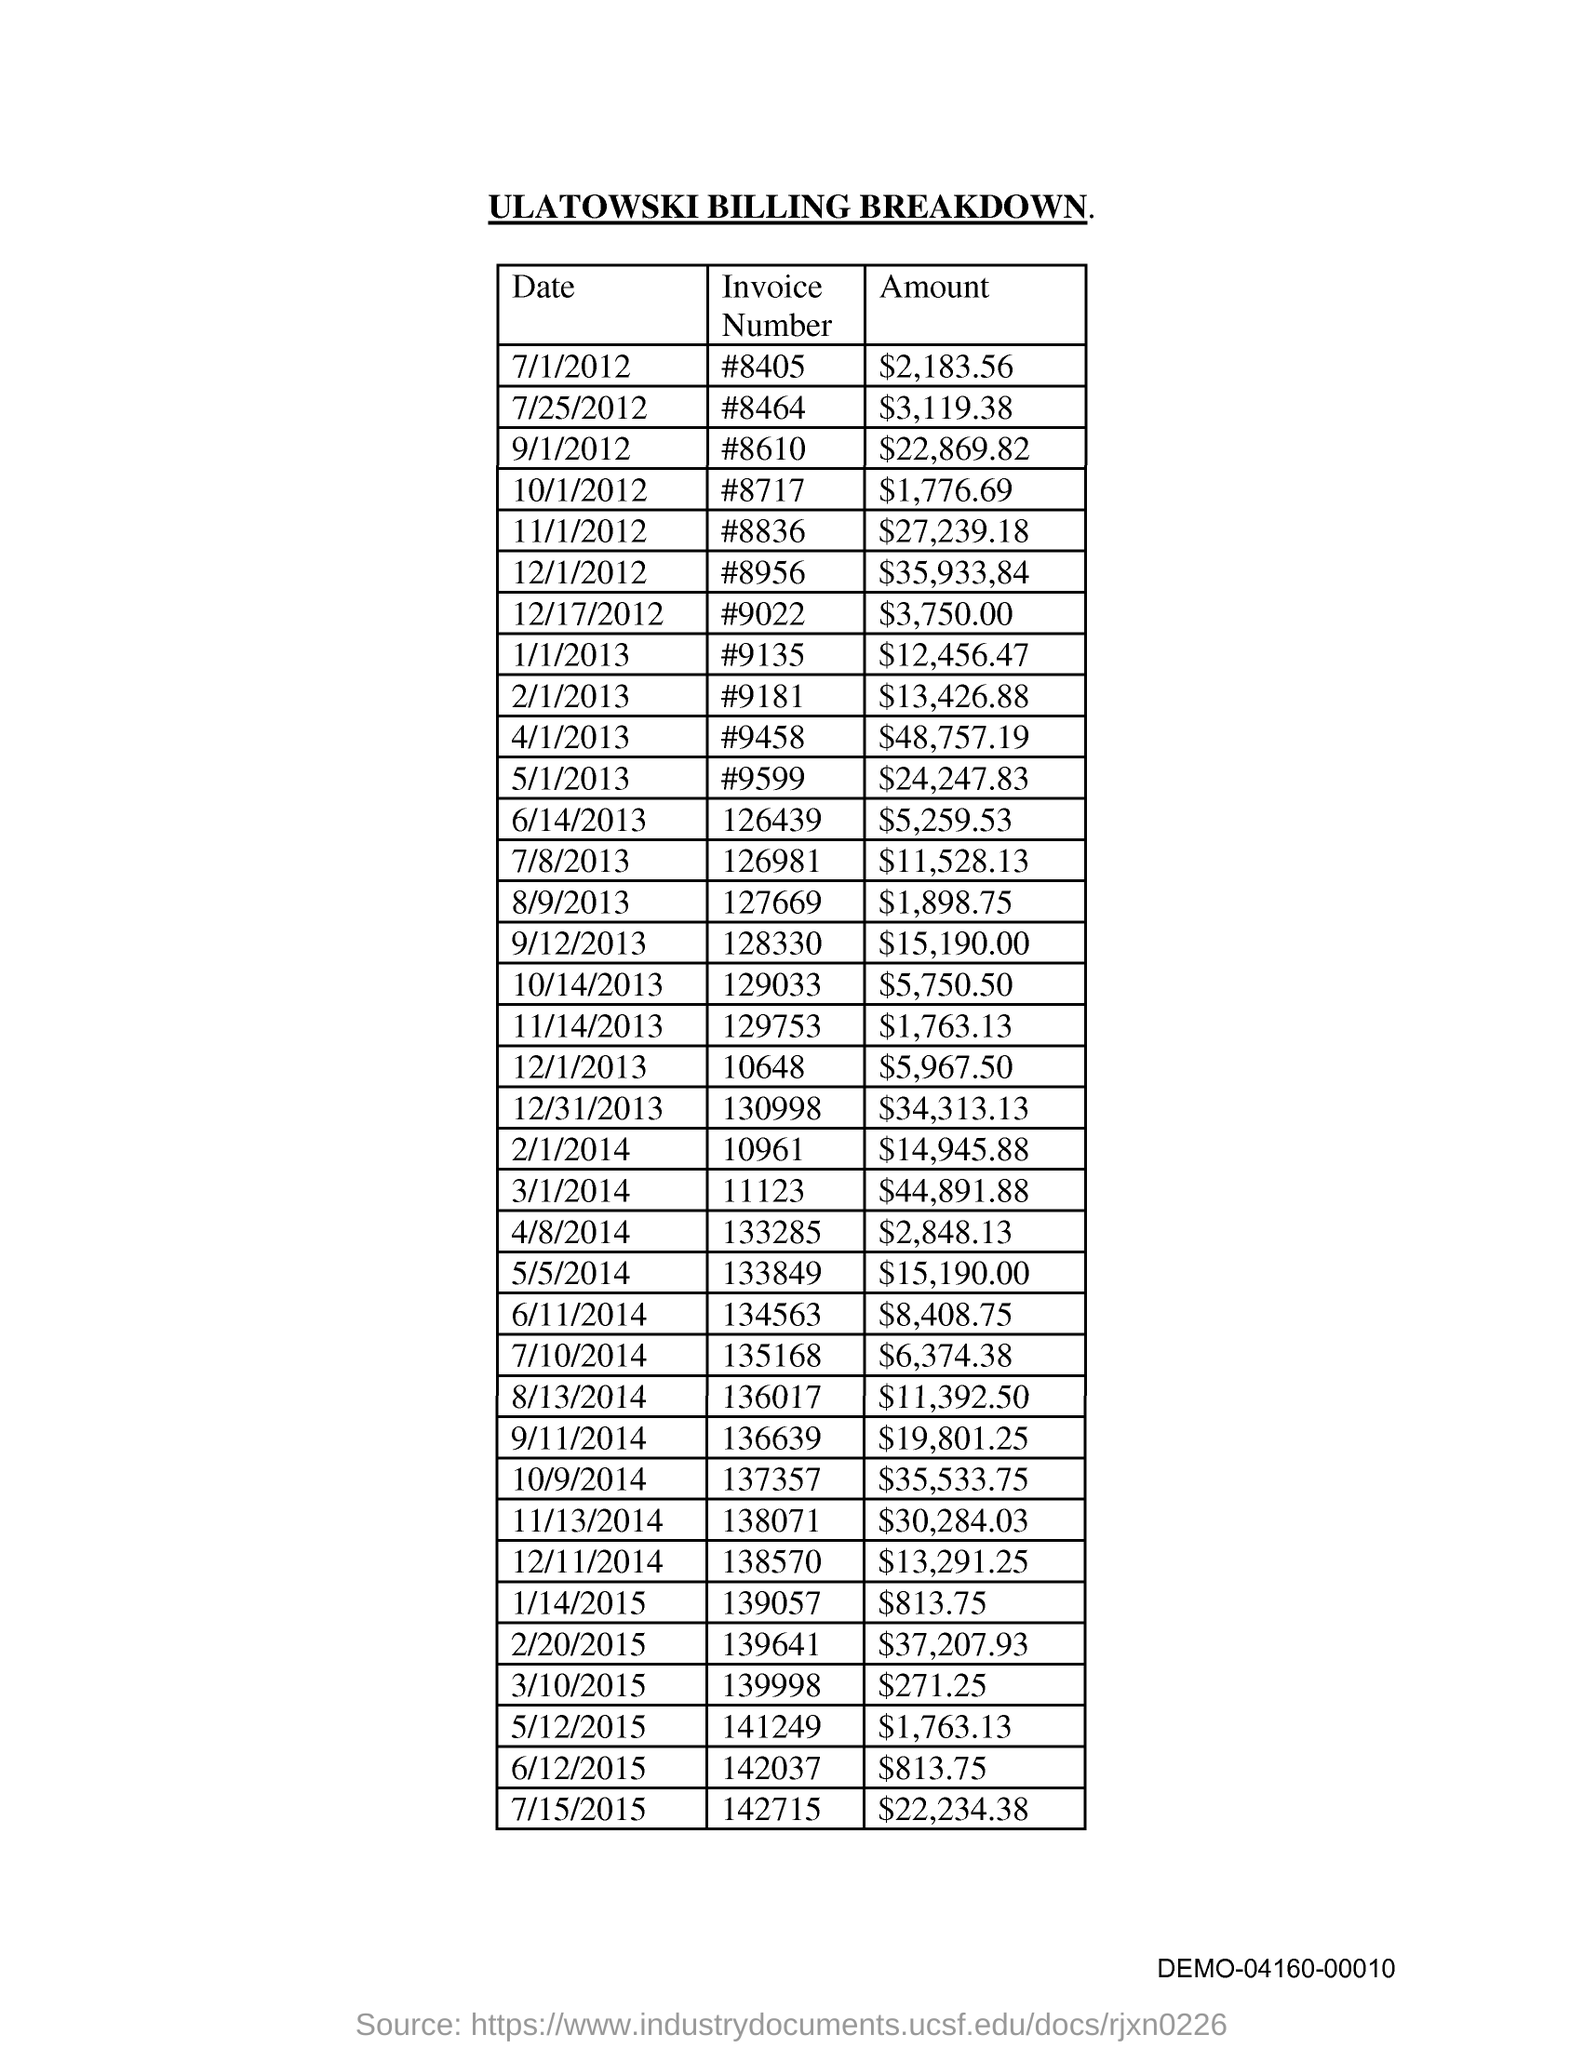Indicate a few pertinent items in this graphic. The title of the document is Ulatowski Billing Breakdown. 